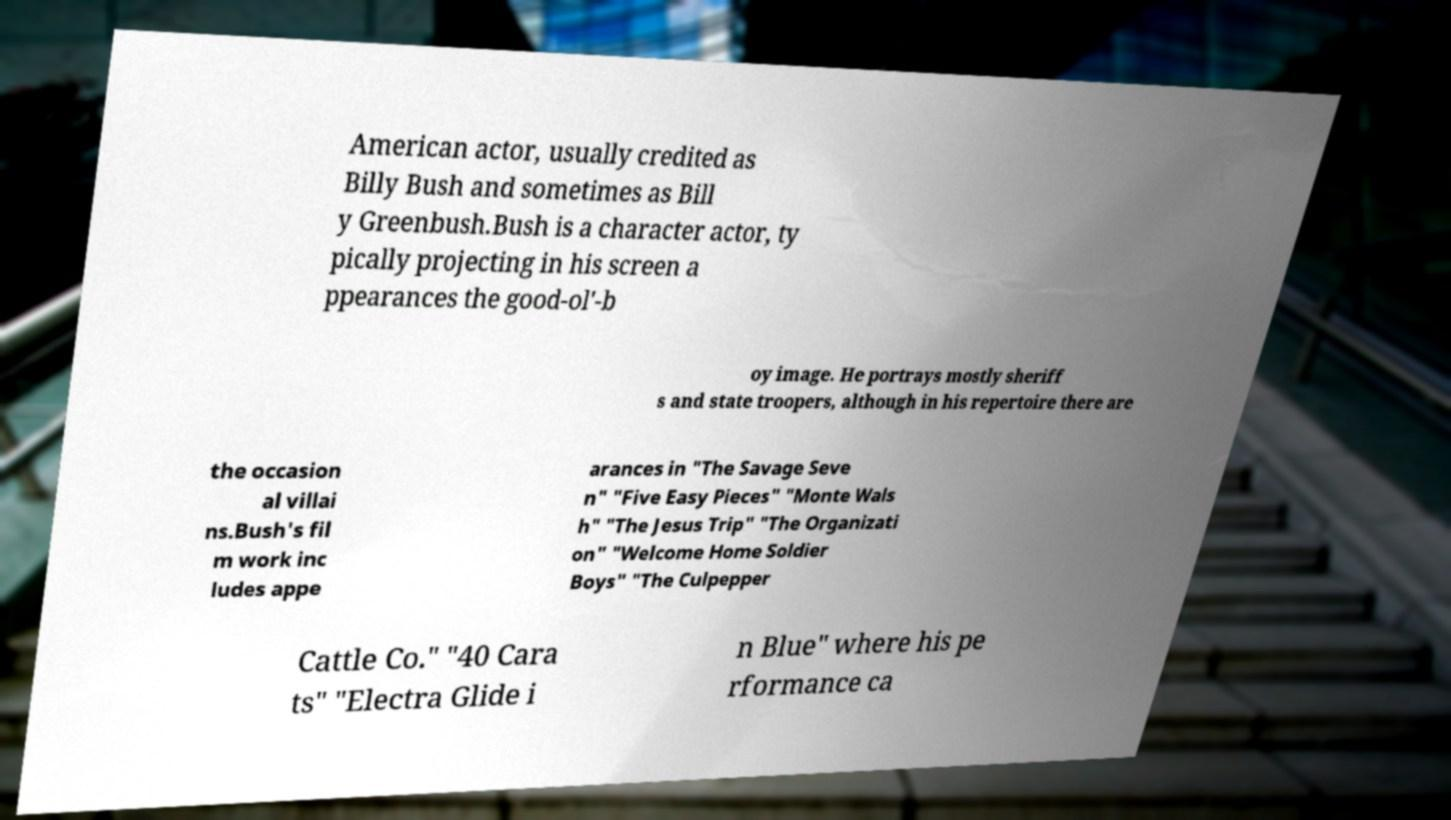Could you assist in decoding the text presented in this image and type it out clearly? American actor, usually credited as Billy Bush and sometimes as Bill y Greenbush.Bush is a character actor, ty pically projecting in his screen a ppearances the good-ol'-b oy image. He portrays mostly sheriff s and state troopers, although in his repertoire there are the occasion al villai ns.Bush's fil m work inc ludes appe arances in "The Savage Seve n" "Five Easy Pieces" "Monte Wals h" "The Jesus Trip" "The Organizati on" "Welcome Home Soldier Boys" "The Culpepper Cattle Co." "40 Cara ts" "Electra Glide i n Blue" where his pe rformance ca 